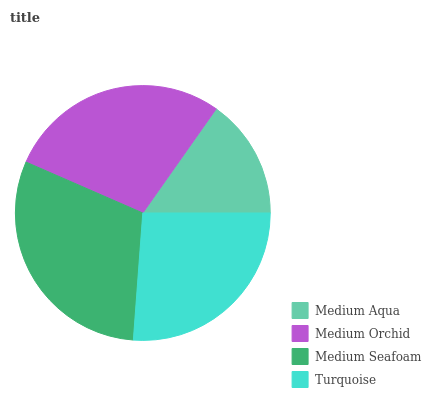Is Medium Aqua the minimum?
Answer yes or no. Yes. Is Medium Seafoam the maximum?
Answer yes or no. Yes. Is Medium Orchid the minimum?
Answer yes or no. No. Is Medium Orchid the maximum?
Answer yes or no. No. Is Medium Orchid greater than Medium Aqua?
Answer yes or no. Yes. Is Medium Aqua less than Medium Orchid?
Answer yes or no. Yes. Is Medium Aqua greater than Medium Orchid?
Answer yes or no. No. Is Medium Orchid less than Medium Aqua?
Answer yes or no. No. Is Medium Orchid the high median?
Answer yes or no. Yes. Is Turquoise the low median?
Answer yes or no. Yes. Is Turquoise the high median?
Answer yes or no. No. Is Medium Orchid the low median?
Answer yes or no. No. 